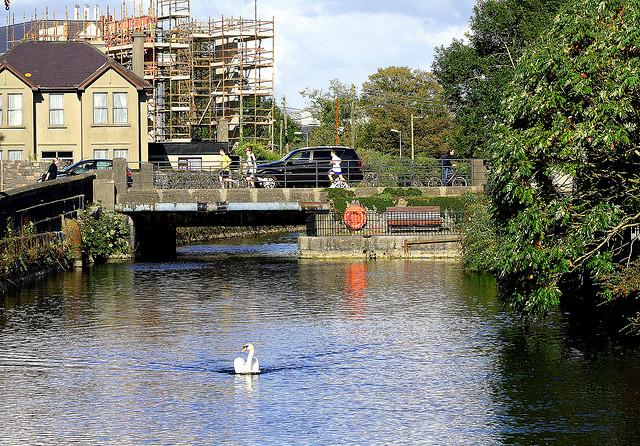Why is he running on the bridge? exercise 